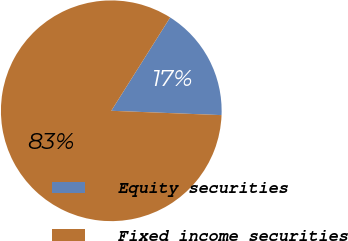Convert chart. <chart><loc_0><loc_0><loc_500><loc_500><pie_chart><fcel>Equity securities<fcel>Fixed income securities<nl><fcel>16.67%<fcel>83.33%<nl></chart> 